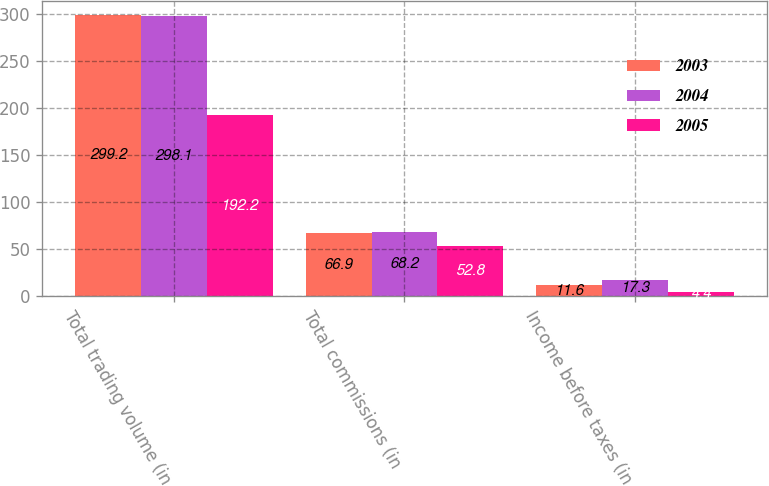<chart> <loc_0><loc_0><loc_500><loc_500><stacked_bar_chart><ecel><fcel>Total trading volume (in<fcel>Total commissions (in<fcel>Income before taxes (in<nl><fcel>2003<fcel>299.2<fcel>66.9<fcel>11.6<nl><fcel>2004<fcel>298.1<fcel>68.2<fcel>17.3<nl><fcel>2005<fcel>192.2<fcel>52.8<fcel>4.4<nl></chart> 